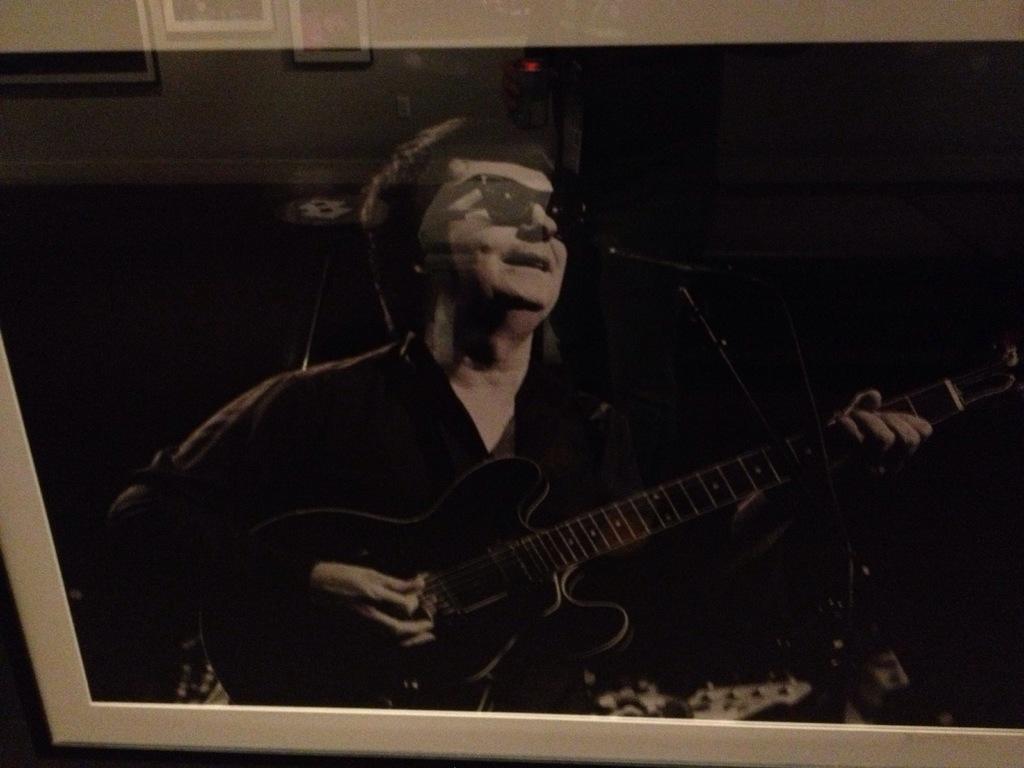Can you describe this image briefly? In this image I can see a person holding a guitar and he is smiling and at the top I can see photo frames attached to the wall. 